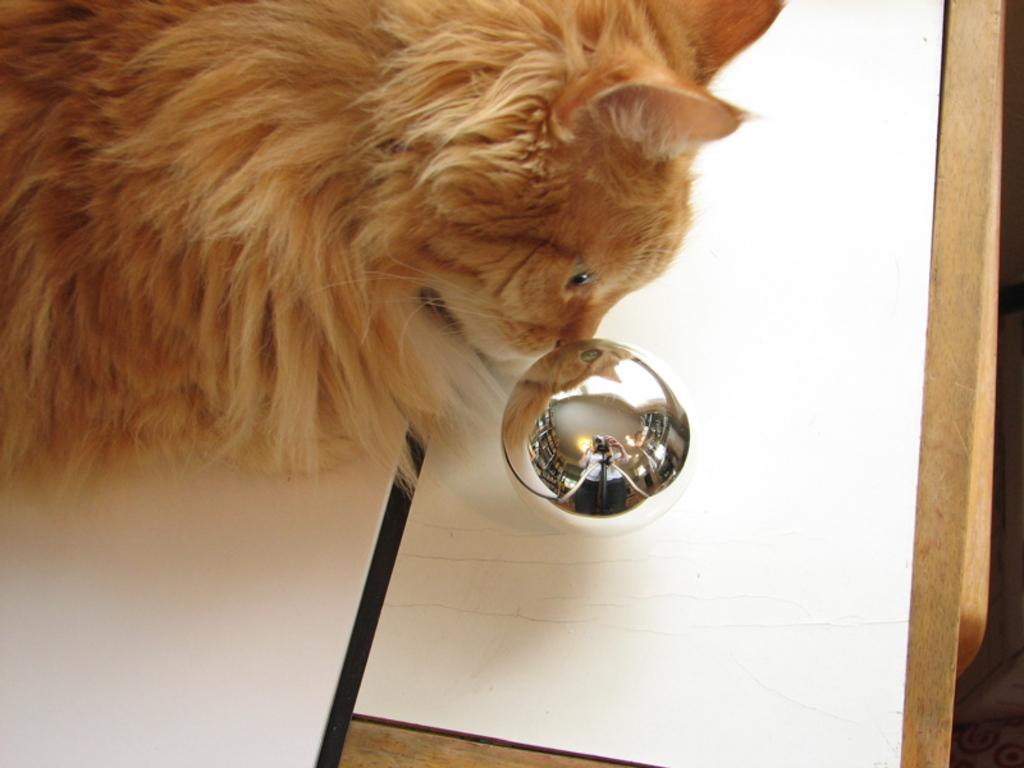What type of creature is in the image? There is an animal in the image. What color is the animal? The animal is brown in color. What other object can be seen in the image? There is a silver-colored object in the image. What is the color of the surface in the image? The image has a white color surface. How many chairs are visible in the image? There are no chairs present in the image. What type of feather can be seen on the animal in the image? There is no feather visible on the animal in the image. 